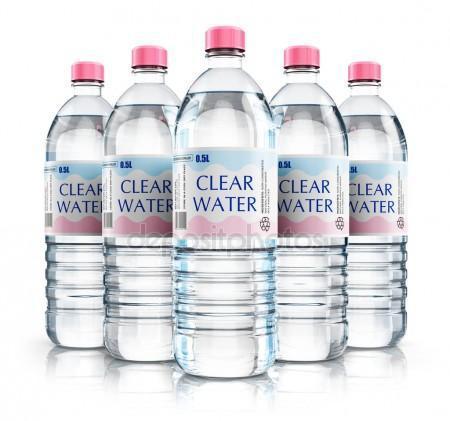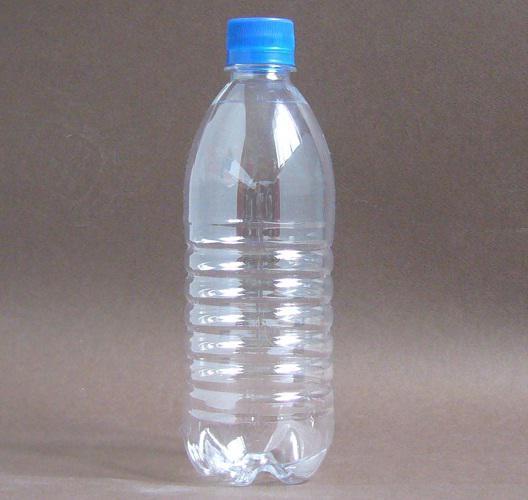The first image is the image on the left, the second image is the image on the right. Analyze the images presented: Is the assertion "The left image shows 5 water bottles lined up in V-formation with the words, """"clear water"""" on them." valid? Answer yes or no. Yes. The first image is the image on the left, the second image is the image on the right. Evaluate the accuracy of this statement regarding the images: "Five identical water bottles are in a V-formation in the image on the left.". Is it true? Answer yes or no. Yes. 